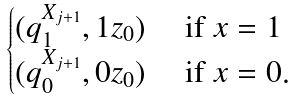Convert formula to latex. <formula><loc_0><loc_0><loc_500><loc_500>\begin{cases} ( q ^ { X _ { j + 1 } } _ { 1 } , 1 z _ { 0 } ) & \text { if } x = 1 \\ ( q ^ { X _ { j + 1 } } _ { 0 } , 0 z _ { 0 } ) & \text { if } x = 0 . \end{cases}</formula> 